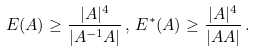<formula> <loc_0><loc_0><loc_500><loc_500>E ( A ) \geq \frac { | A | ^ { 4 } } { | A ^ { - 1 } A | } \, , \, E ^ { * } ( A ) \geq \frac { | A | ^ { 4 } } { | A A | } \, .</formula> 